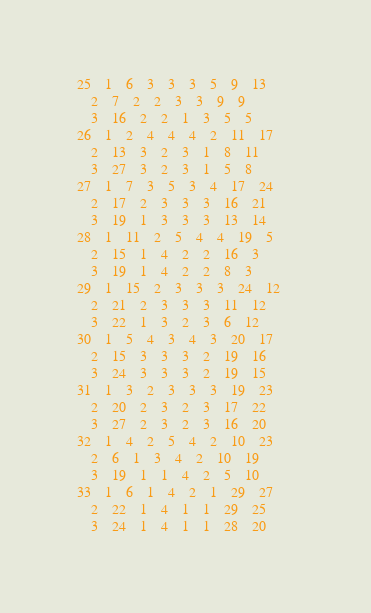Convert code to text. <code><loc_0><loc_0><loc_500><loc_500><_ObjectiveC_>25	1	6	3	3	3	5	9	13	
	2	7	2	2	3	3	9	9	
	3	16	2	2	1	3	5	5	
26	1	2	4	4	4	2	11	17	
	2	13	3	2	3	1	8	11	
	3	27	3	2	3	1	5	8	
27	1	7	3	5	3	4	17	24	
	2	17	2	3	3	3	16	21	
	3	19	1	3	3	3	13	14	
28	1	11	2	5	4	4	19	5	
	2	15	1	4	2	2	16	3	
	3	19	1	4	2	2	8	3	
29	1	15	2	3	3	3	24	12	
	2	21	2	3	3	3	11	12	
	3	22	1	3	2	3	6	12	
30	1	5	4	3	4	3	20	17	
	2	15	3	3	3	2	19	16	
	3	24	3	3	3	2	19	15	
31	1	3	2	3	3	3	19	23	
	2	20	2	3	2	3	17	22	
	3	27	2	3	2	3	16	20	
32	1	4	2	5	4	2	10	23	
	2	6	1	3	4	2	10	19	
	3	19	1	1	4	2	5	10	
33	1	6	1	4	2	1	29	27	
	2	22	1	4	1	1	29	25	
	3	24	1	4	1	1	28	20	</code> 